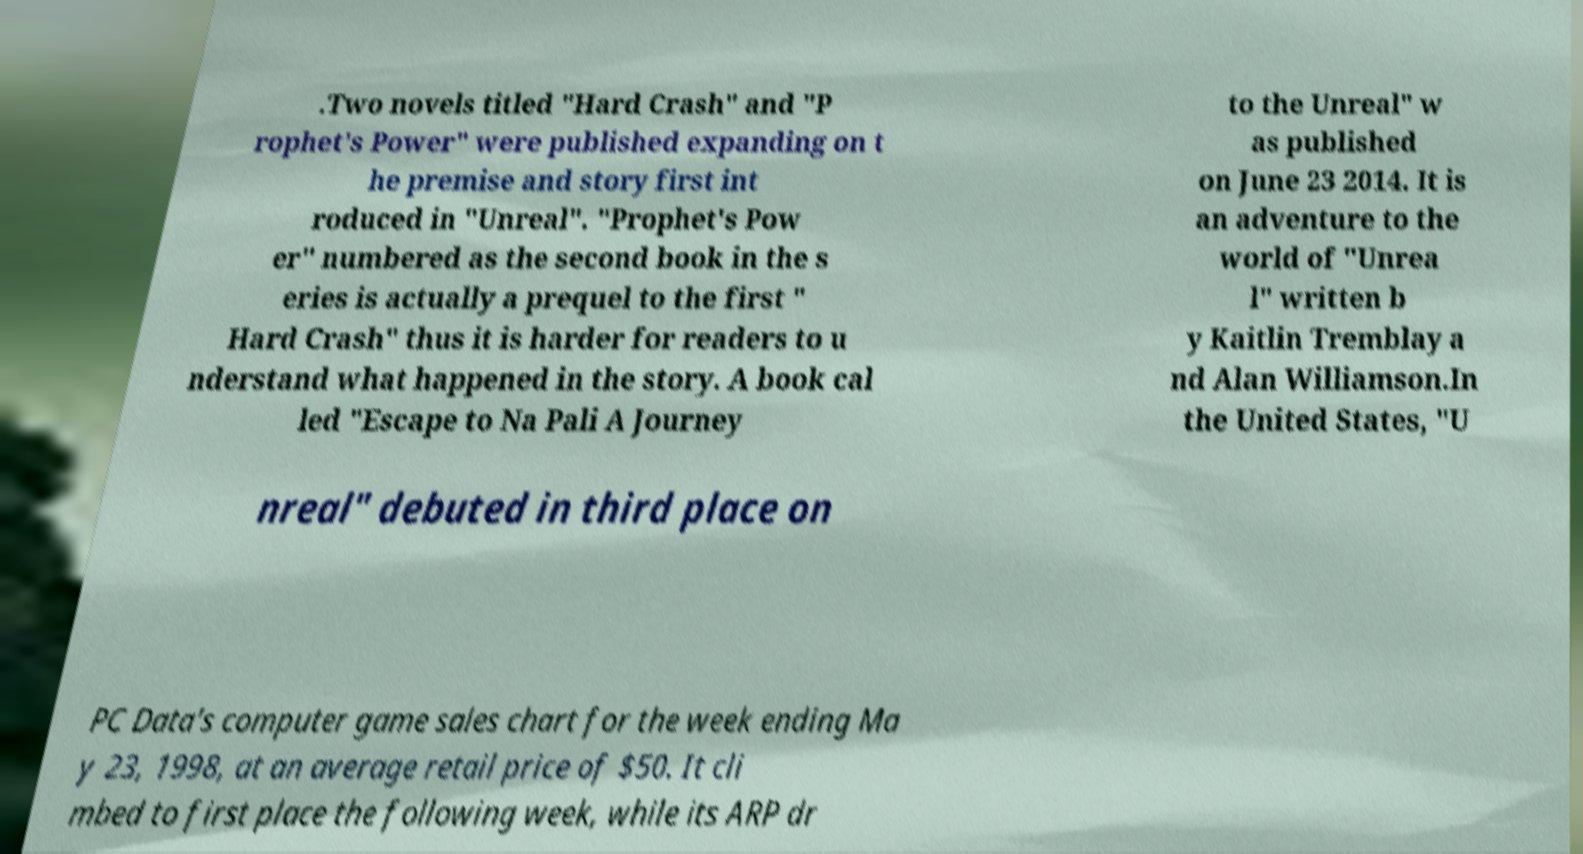Can you read and provide the text displayed in the image?This photo seems to have some interesting text. Can you extract and type it out for me? .Two novels titled "Hard Crash" and "P rophet's Power" were published expanding on t he premise and story first int roduced in "Unreal". "Prophet's Pow er" numbered as the second book in the s eries is actually a prequel to the first " Hard Crash" thus it is harder for readers to u nderstand what happened in the story. A book cal led "Escape to Na Pali A Journey to the Unreal" w as published on June 23 2014. It is an adventure to the world of "Unrea l" written b y Kaitlin Tremblay a nd Alan Williamson.In the United States, "U nreal" debuted in third place on PC Data's computer game sales chart for the week ending Ma y 23, 1998, at an average retail price of $50. It cli mbed to first place the following week, while its ARP dr 